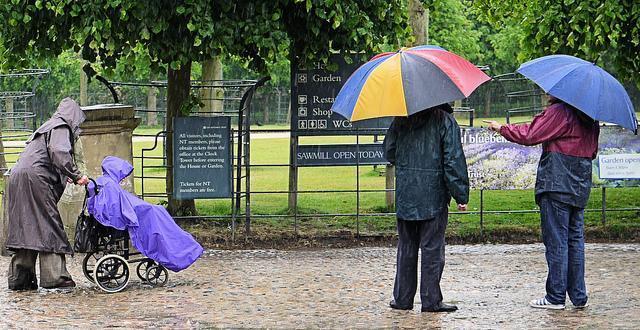How many umbrellas are there?
Give a very brief answer. 2. How many people can you see?
Give a very brief answer. 4. 